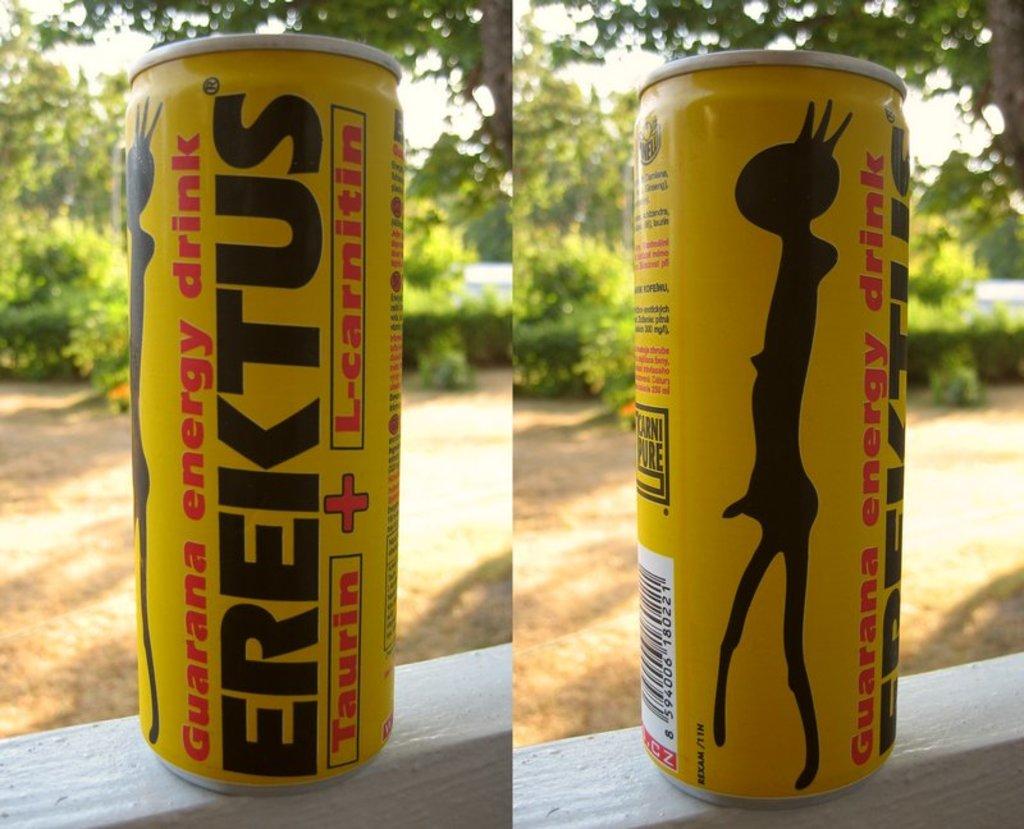What is an active ingredient in this beverage?
Make the answer very short. Guarana. One ingredient is taurin?
Your answer should be compact. Yes. 